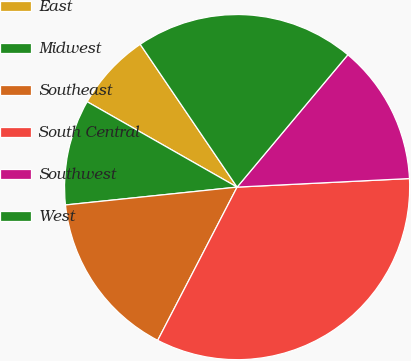Convert chart. <chart><loc_0><loc_0><loc_500><loc_500><pie_chart><fcel>East<fcel>Midwest<fcel>Southeast<fcel>South Central<fcel>Southwest<fcel>West<nl><fcel>7.27%<fcel>9.89%<fcel>15.74%<fcel>33.4%<fcel>13.12%<fcel>20.58%<nl></chart> 